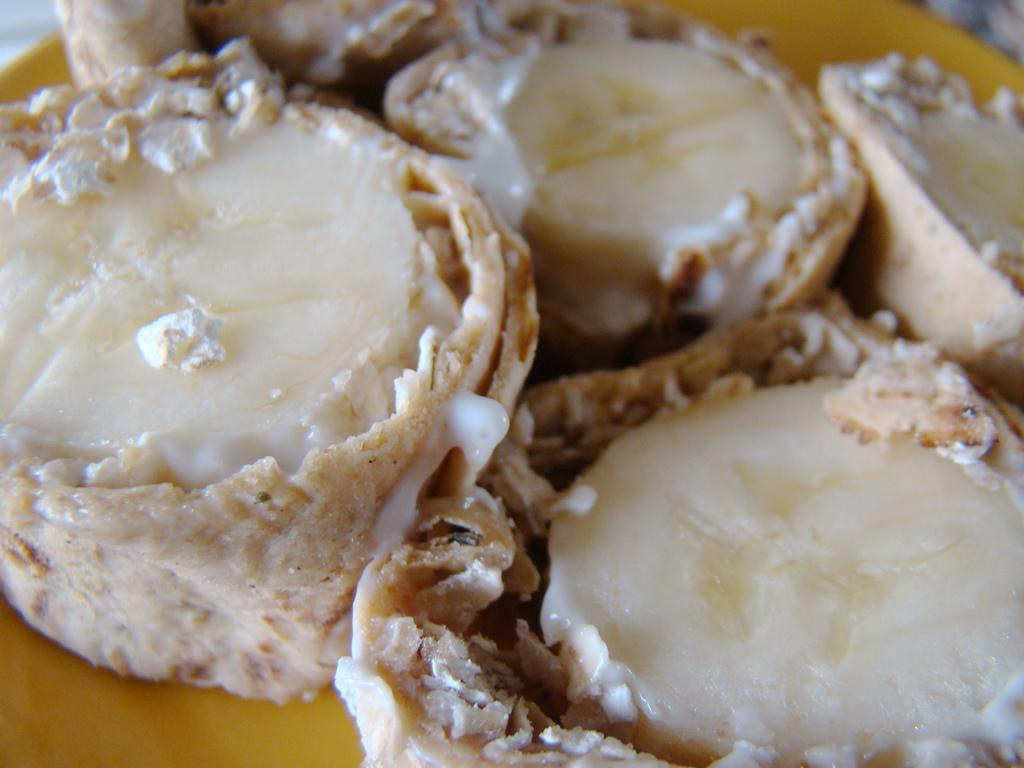What is on the plate in the image? There is a plate containing desserts in the image. Can you describe the desserts on the plate? Unfortunately, the specific desserts cannot be identified from the image alone. What might someone do with the desserts on the plate? Someone might eat the desserts on the plate. What type of trail can be seen in the image? There is no trail present in the image; it features a plate containing desserts. Can you hear the owl hooting in the image? There is no sound in the image, and therefore no owl can be heard. 